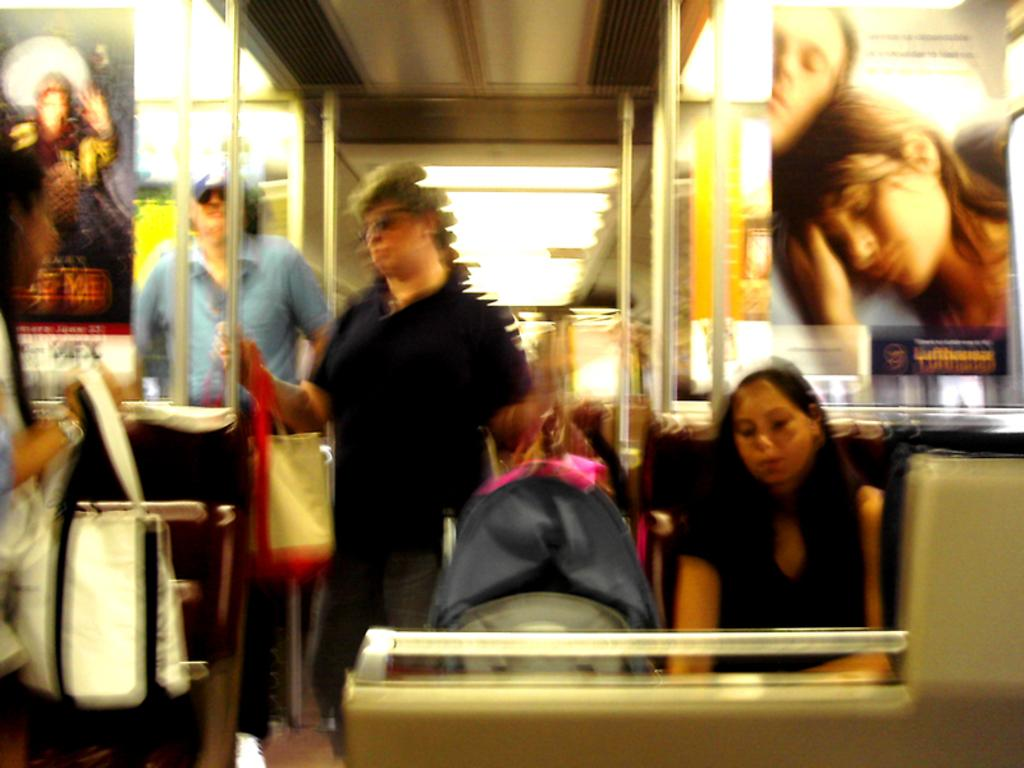How many people are present in the image? There are two persons standing in the image. What are the two persons holding in their hands? The two persons are holding carry bags in their hands. Can you describe the lady's position in the image? There is a lady sitting in the right corner of the image. Is there anyone else visible in the image besides the two standing persons and the sitting lady? Yes, there is a person standing in the background of the image. What type of drug can be seen in the hands of the person standing in the background? There is no drug present in the image; the two persons standing are holding carry bags. 